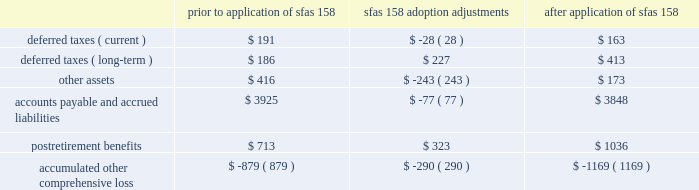Part ii , item 8 20 .
Pension and other benefit plans adoption of sfas 158 in september 2006 , the financial accounting standards board issued sfas 158 ( employer 2019s accounting for defined benefit pension and other postretirement plans , an amendment of fasb statements no .
87 , 88 , 106 and 132 ( r ) ) .
Sfas 158 required schlumberger to recognize the funded status ( i.e. , the difference between the fair value of plan assets and the benefit obligation ) of its defined benefit pension and other postretirement plans ( collectively 201cpostretirement benefit plans 201d ) in its december 31 , 2006 consolidated balance sheet , with a corresponding adjustment to accumulated other comprehensive income , net of tax .
The adjustment to accumulated other comprehensive income at adoption represents the net unrecognized actuarial losses and unrecognized prior service costs which were previously netted against schlumberger 2019s postretirement benefit plans 2019 funded status in the consolidated balance sheet pursuant to the provisions of sfas 87 ( employers 2019 accounting for pensions ) and sfas 106 ( employer 2019s accounting for postretirement benefits other than pensions ) .
These amounts will subsequently be recognized as net periodic postretirement cost consistent with schlumberger 2019s historical accounting policy for amortizing such amounts .
The adoption of sfas 158 had no effect on schlumberger 2019s consolidated statement of income for the year ended december 31 , 2006 , or for any prior period , and it will not affect schlumberger 2019s operating results in future periods .
Additionally , sfas 158 did not have an effect on schlumberger 2019s consolidated balance sheet at december 31 , sfas 158 also required companies to measure the fair value of plan assets and benefit obligations as of the date of the fiscal year-end balance sheet .
This provision of sfas 158 is not applicable as schlumberger already uses a measurement date of december 31 for its postretirement benefit plans .
The incremental effect of applying sfas 158 on the consolidated balance sheet at december 31 , 2006 for all of schlumberger 2019s postretirement benefit plans is presented in the table : ( stated in millions ) prior to application of sfas 158 sfas 158 adoption adjustments application of sfas 158 .
As a result of the adoption of sfas 158 , schlumberger 2019s total liabilities increased by approximately 2% ( 2 % ) and stockholders 2019 equity decreased by approximately 3% ( 3 % ) .
The impact on schlumberger 2019s total assets was insignificant .
United states defined benefit pension plans schlumberger and its united states subsidiary sponsor several defined benefit pension plans that cover substantially all employees hired prior to october 1 , 2004 .
The benefits are based on years of service and compensation on a career-average pay basis .
The funding policy with respect to qualified pension plans is to annually contribute amounts that are based upon a number of factors including the actuarial accrued liability , amounts that are deductible for income tax purposes , legal funding requirements and available cash flow .
These contributions are intended to provide for benefits earned to date and those expected to be earned in the future. .
What was the combined change to the tax liabilities both current and long-term following the sfas 158 adoption adjustments? 
Rationale: the combined amount in tax liability adjustment is the some of the current amount and the long term amount
Computations: ((28 * const_m1) + 227)
Answer: 199.0. 